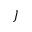Convert formula to latex. <formula><loc_0><loc_0><loc_500><loc_500>J</formula> 